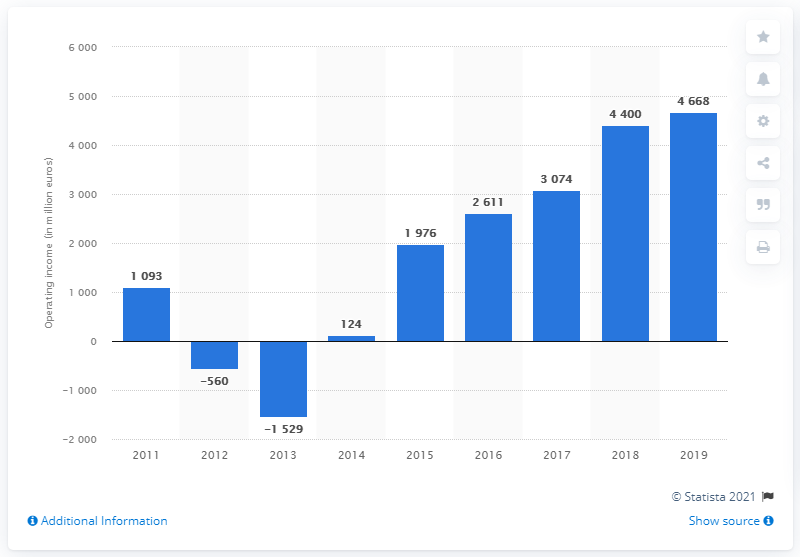Identify some key points in this picture. PSA Group reported operating income of 4,400 in 2018. In 2018, PSA Group's operating income was 4,400. 